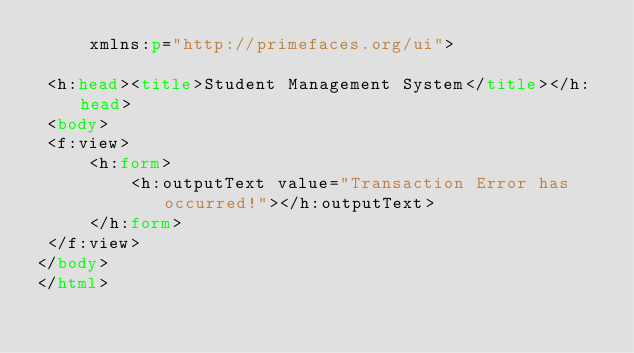<code> <loc_0><loc_0><loc_500><loc_500><_HTML_>     xmlns:p="http://primefaces.org/ui">  

 <h:head><title>Student Management System</title></h:head>
 <body>
 <f:view>
     <h:form>
         <h:outputText value="Transaction Error has occurred!"></h:outputText>
     </h:form>
 </f:view>
</body>
</html></code> 